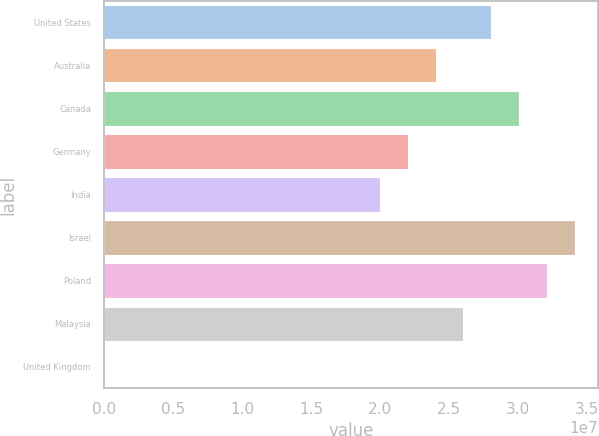Convert chart. <chart><loc_0><loc_0><loc_500><loc_500><bar_chart><fcel>United States<fcel>Australia<fcel>Canada<fcel>Germany<fcel>India<fcel>Israel<fcel>Poland<fcel>Malaysia<fcel>United Kingdom<nl><fcel>2.8032e+07<fcel>2.4002e+07<fcel>3.0047e+07<fcel>2.1987e+07<fcel>1.9972e+07<fcel>3.4077e+07<fcel>3.2062e+07<fcel>2.6017e+07<fcel>2017<nl></chart> 